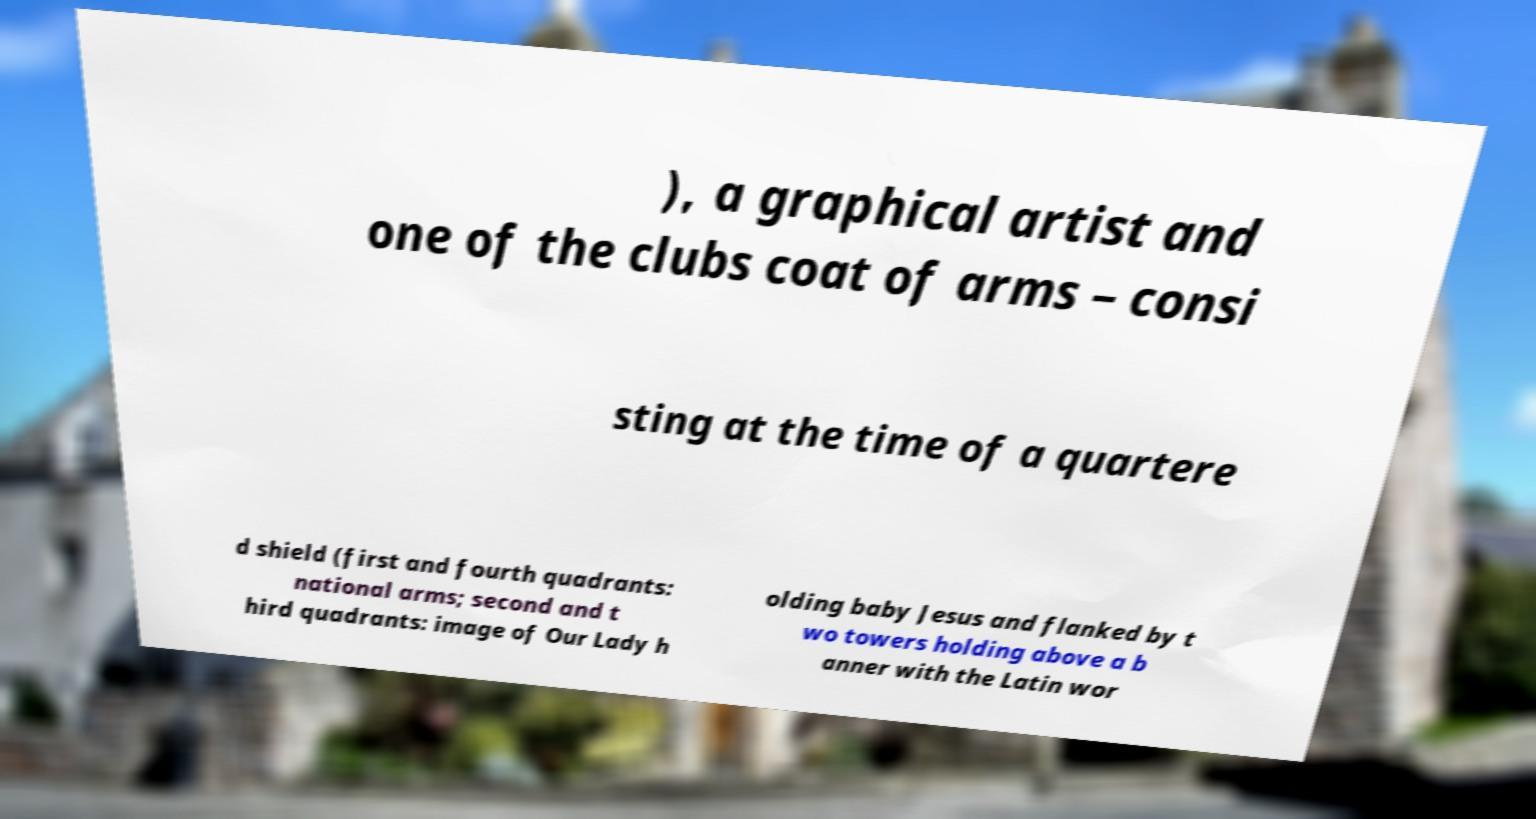What messages or text are displayed in this image? I need them in a readable, typed format. ), a graphical artist and one of the clubs coat of arms – consi sting at the time of a quartere d shield (first and fourth quadrants: national arms; second and t hird quadrants: image of Our Lady h olding baby Jesus and flanked by t wo towers holding above a b anner with the Latin wor 